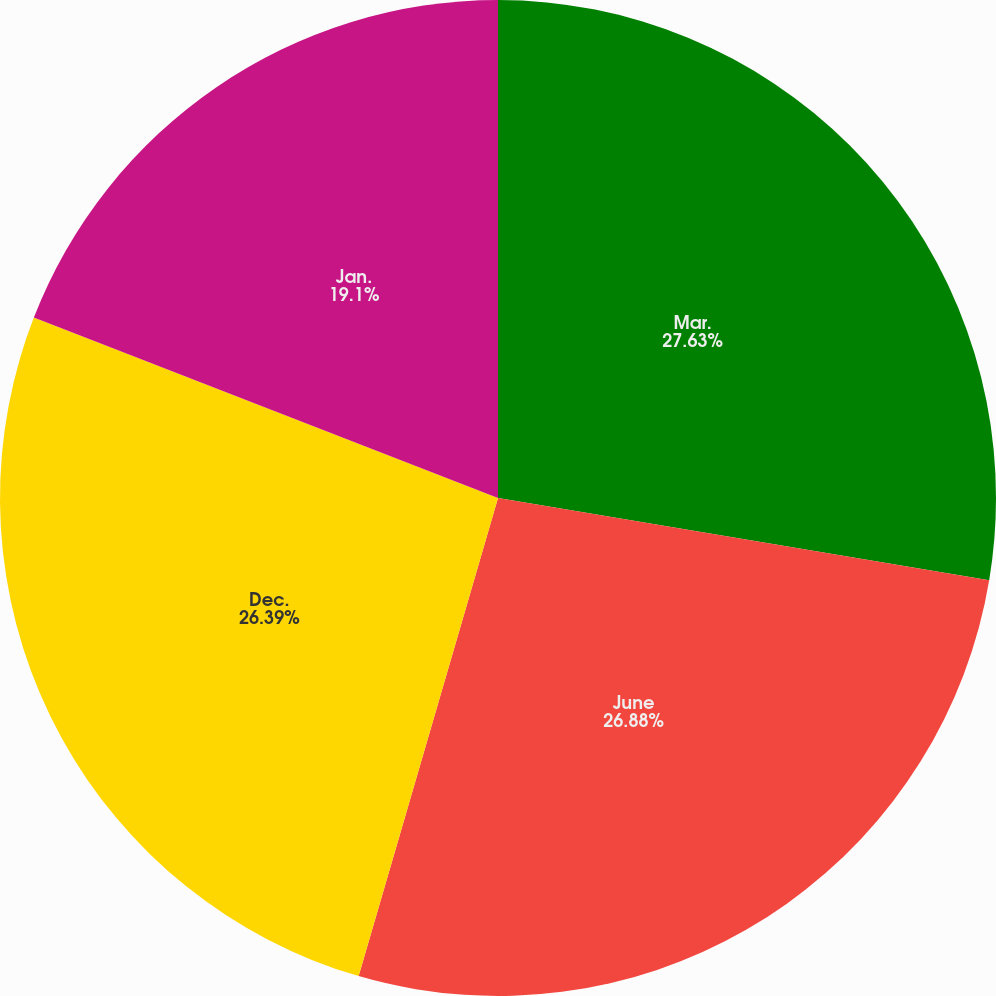<chart> <loc_0><loc_0><loc_500><loc_500><pie_chart><fcel>Mar.<fcel>June<fcel>Dec.<fcel>Jan.<nl><fcel>27.64%<fcel>26.88%<fcel>26.39%<fcel>19.1%<nl></chart> 